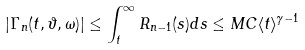<formula> <loc_0><loc_0><loc_500><loc_500>| \Gamma _ { n } ( t , \vartheta , \omega ) | \leq \int _ { t } ^ { \infty } R _ { n - 1 } ( s ) d s \leq M C \langle t \rangle ^ { \gamma - 1 }</formula> 